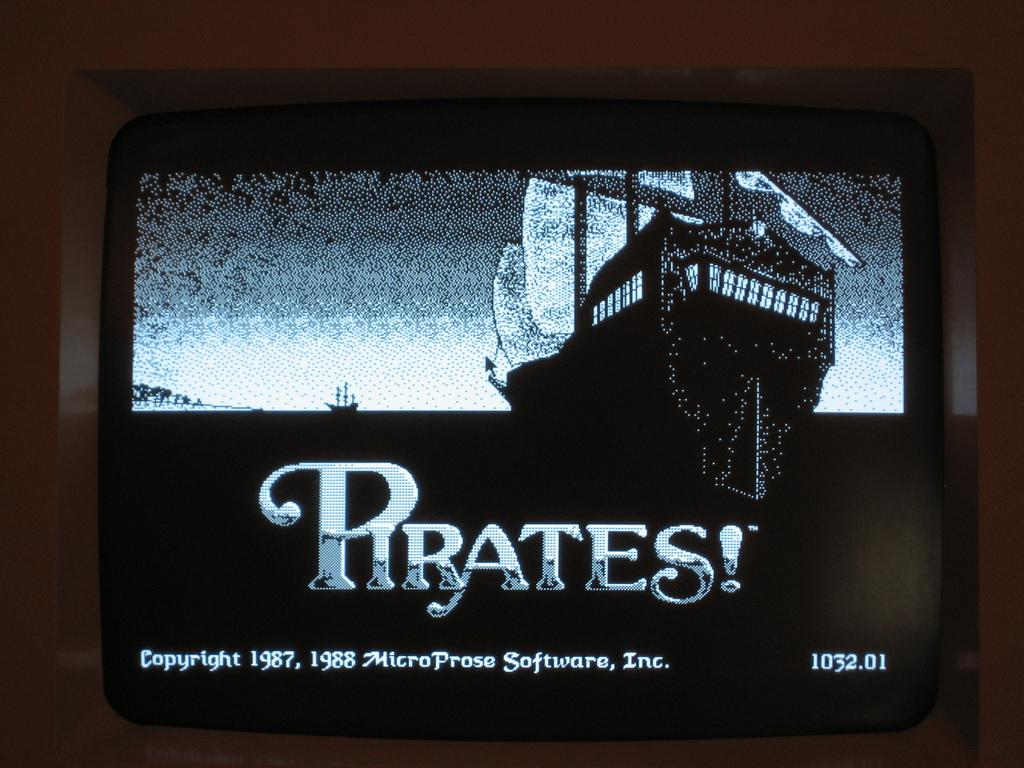Provide a one-sentence caption for the provided image. An old television screen showing a game called Pirates. 